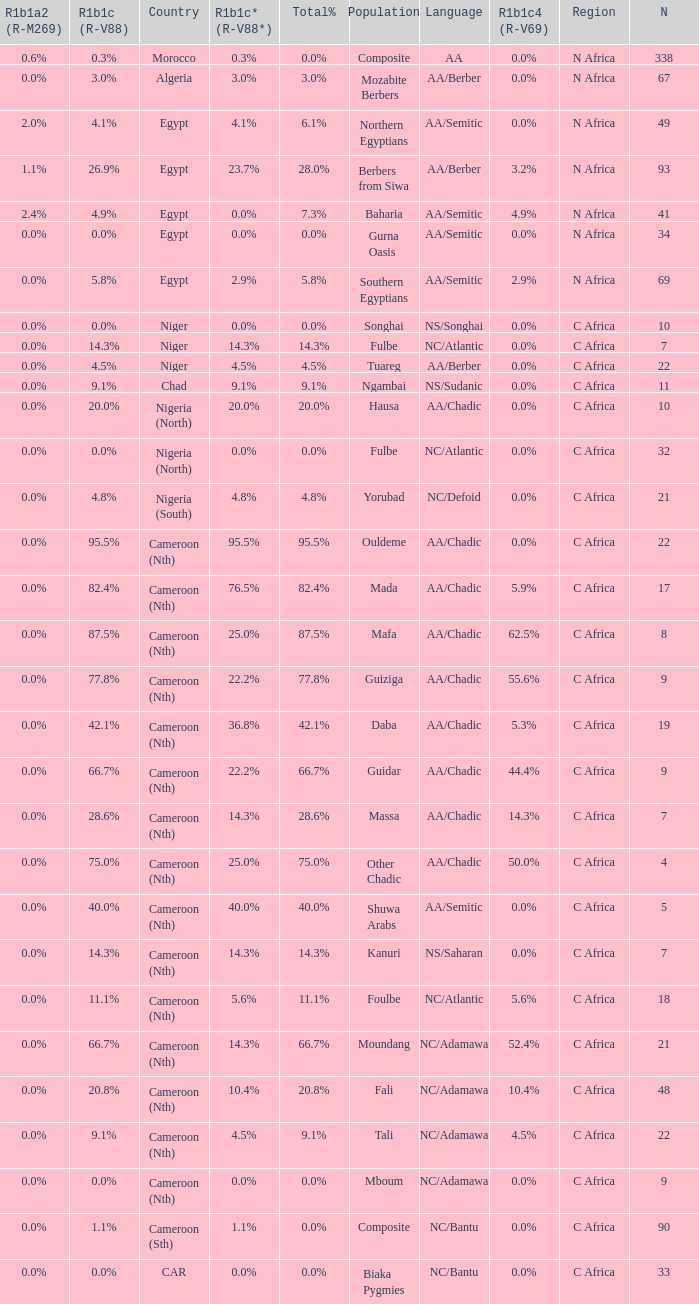What languages are spoken in Niger with r1b1c (r-v88) of 0.0%? NS/Songhai. 